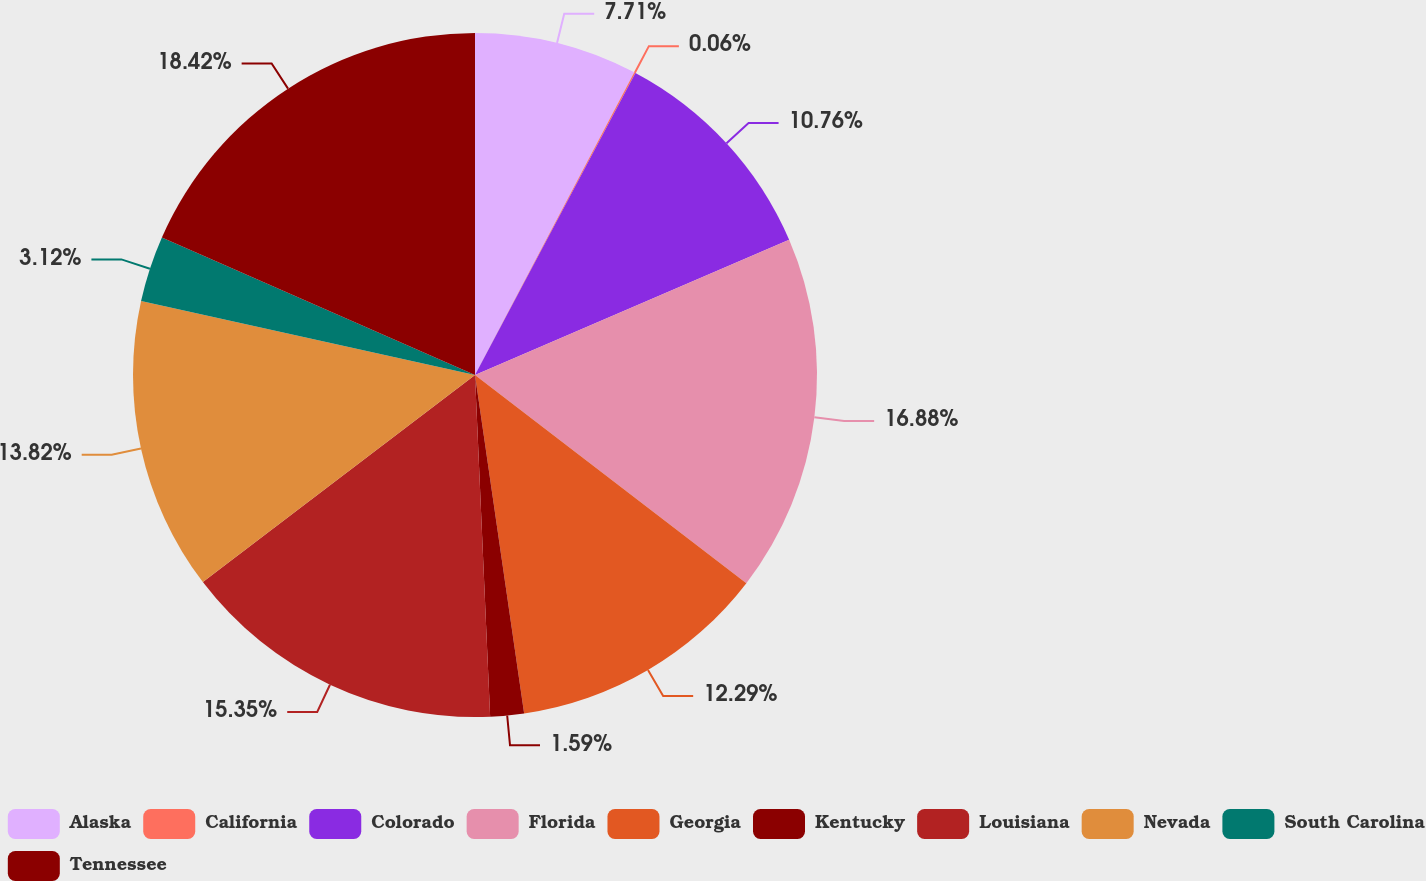Convert chart. <chart><loc_0><loc_0><loc_500><loc_500><pie_chart><fcel>Alaska<fcel>California<fcel>Colorado<fcel>Florida<fcel>Georgia<fcel>Kentucky<fcel>Louisiana<fcel>Nevada<fcel>South Carolina<fcel>Tennessee<nl><fcel>7.71%<fcel>0.06%<fcel>10.76%<fcel>16.88%<fcel>12.29%<fcel>1.59%<fcel>15.35%<fcel>13.82%<fcel>3.12%<fcel>18.41%<nl></chart> 